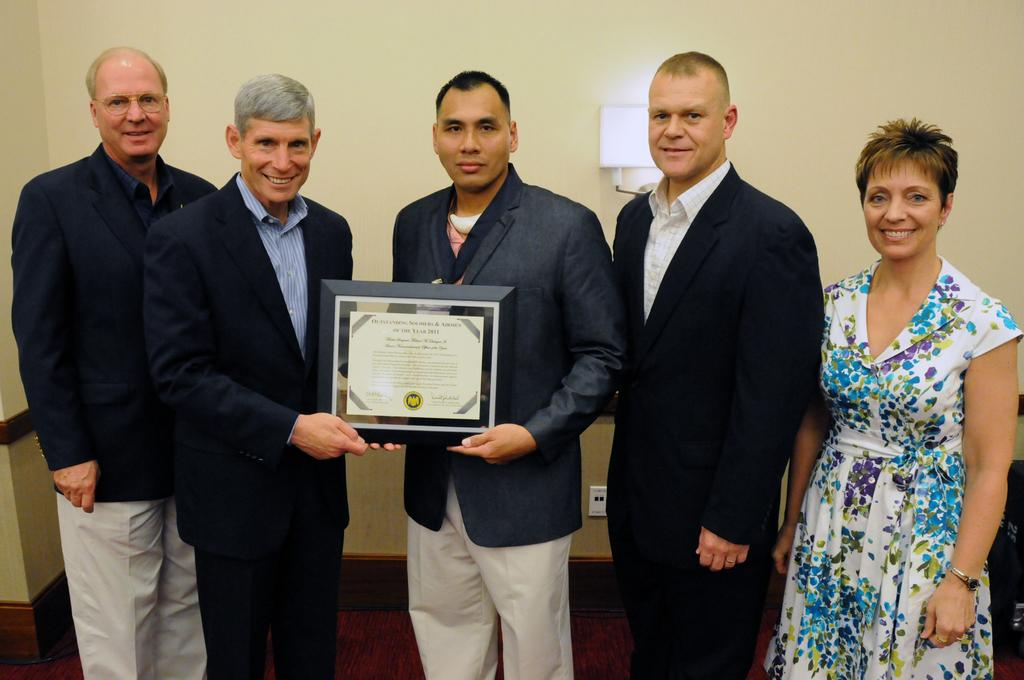How many people are in the image? There are people in the image, but the exact number is not specified. What are the people doing in the image? The people are standing and smiling in the image. What objects are the people holding in the image? Two people are holding shields in the image. What can be seen in the background of the image? There is a wall in the background of the image. What is at the bottom of the image? There is a floor at the bottom of the image. How many minutes does it take for the woman to complete her task in the image? There is no woman or task present in the image, so it is not possible to determine how many minutes it would take to complete a task. 